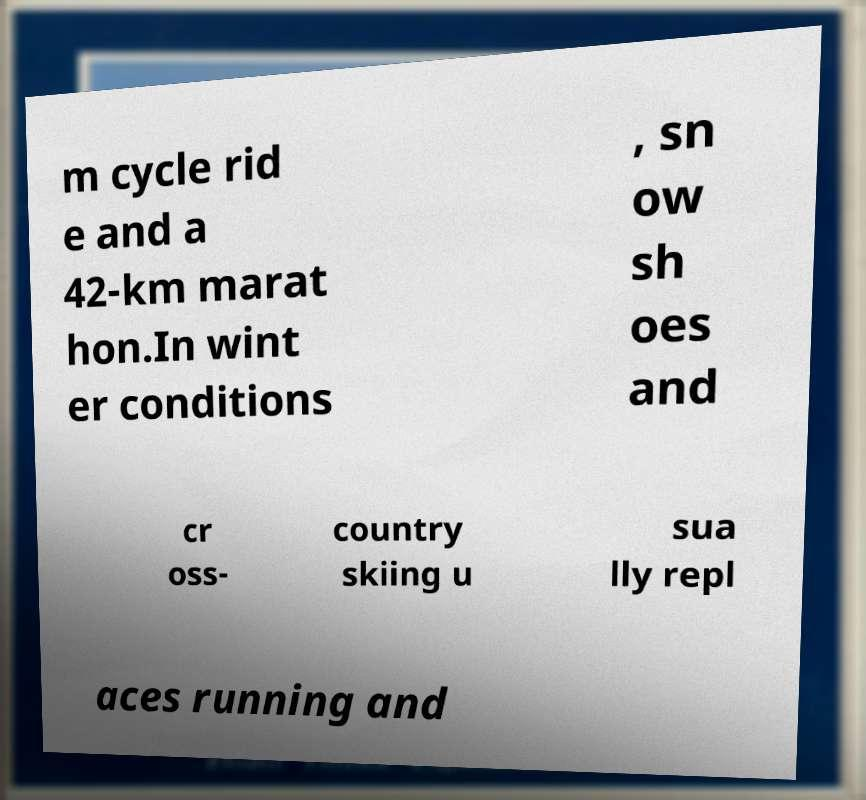What messages or text are displayed in this image? I need them in a readable, typed format. m cycle rid e and a 42-km marat hon.In wint er conditions , sn ow sh oes and cr oss- country skiing u sua lly repl aces running and 